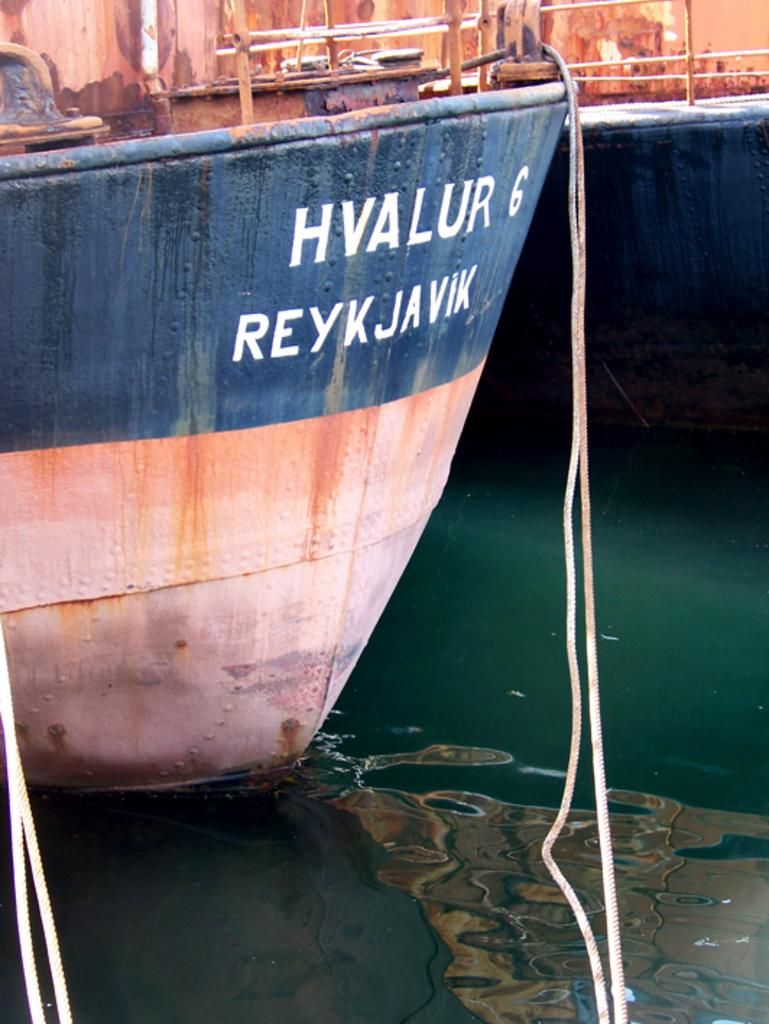What is the main subject of the image? The main subject of the image is ships. Where are the ships located? The ships are on the water. What can be seen in addition to the ships? There are ropes visible in the image. Is there any text or writing on the ships? Yes, there is writing on one of the ships. How many cherries are on the deck of the ship in the image? There are no cherries present in the image. What type of doctor is standing on the ship in the image? There are no doctors present in the image. 